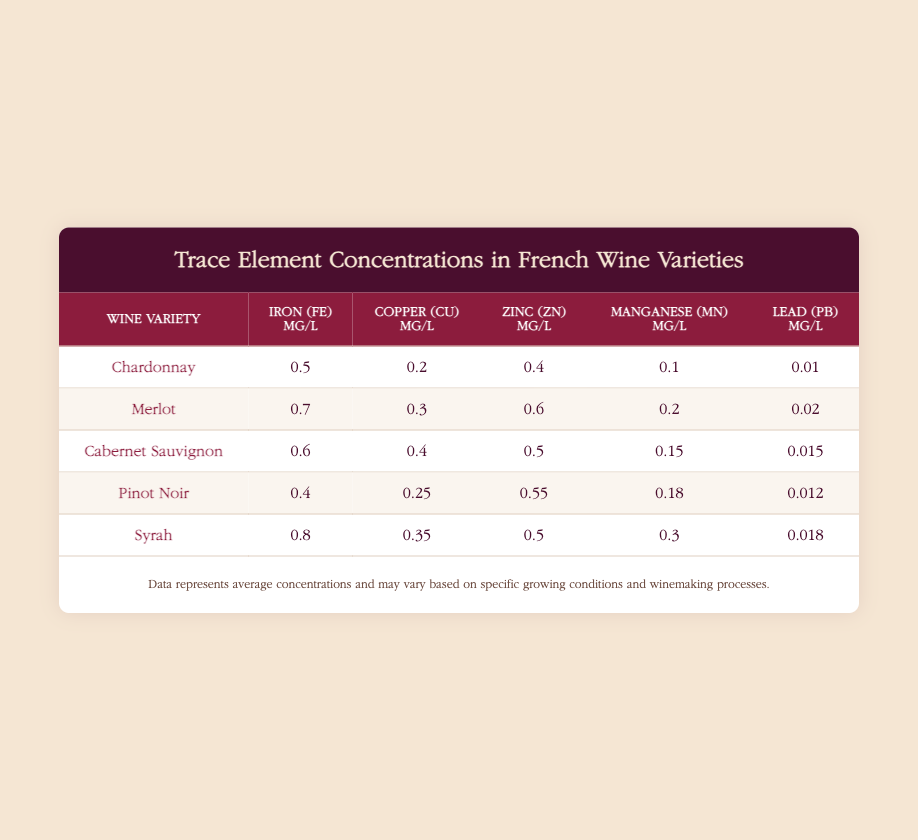What is the concentration of Iron (Fe) in Chardonnay? The table lists the concentration of Iron (Fe) for each wine variety. For Chardonnay, it shows 0.5 mg/L.
Answer: 0.5 mg/L Which wine variety has the highest concentration of Zinc (Zn)? Looking through the Zinc (Zn) concentration values in the table, we find Syrah at 0.5 mg/L and Merlot at 0.6 mg/L. Thus, Merlot has the highest concentration of Zinc (Zn).
Answer: Merlot What is the average concentration of Copper (Cu) across all wine varieties? To calculate the average concentration of Copper (Cu), we first sum the concentrations: 0.2 + 0.3 + 0.4 + 0.25 + 0.35 = 1.5 mg/L. There are 5 varieties, so the average is 1.5/5 = 0.3 mg/L.
Answer: 0.3 mg/L Does Pinot Noir have more than 0.4 mg/L of Lead (Pb)? Referring to the table, the concentration of Lead (Pb) in Pinot Noir is 0.012 mg/L, which is less than 0.4 mg/L.
Answer: No Which wine variety has the highest concentration of Manganese (Mn), and what is that concentration? The Manganese (Mn) concentrations are: Chardonnay at 0.1 mg/L, Merlot at 0.2 mg/L, Cabernet Sauvignon at 0.15 mg/L, Pinot Noir at 0.18 mg/L, and Syrah at 0.3 mg/L. Syrah has the highest concentration at 0.3 mg/L.
Answer: Syrah, 0.3 mg/L If we combine the Lead (Pb) concentrations of all wine varieties, what would be the total concentration? The Lead (Pb) concentrations are: Chardonnay 0.01 mg/L, Merlot 0.02 mg/L, Cabernet Sauvignon 0.015 mg/L, Pinot Noir 0.012 mg/L, and Syrah 0.018 mg/L. Adding these values gives us: 0.01 + 0.02 + 0.015 + 0.012 + 0.018 = 0.075 mg/L.
Answer: 0.075 mg/L Is the concentration of Iron (Fe) in Cabernet Sauvignon less than that in Syrah? The table shows Iron (Fe) concentrations: Cabernet Sauvignon has 0.6 mg/L and Syrah has 0.8 mg/L. Therefore, 0.6 mg/L is less than 0.8 mg/L.
Answer: Yes Which wine variety has the lowest concentration of Manganese (Mn)? By inspecting the Manganese (Mn) values: Chardonnay at 0.1 mg/L, Merlot at 0.2 mg/L, Cabernet Sauvignon at 0.15 mg/L, Pinot Noir at 0.18 mg/L, and Syrah at 0.3 mg/L, we find that Chardonnay has the lowest concentration at 0.1 mg/L.
Answer: Chardonnay 